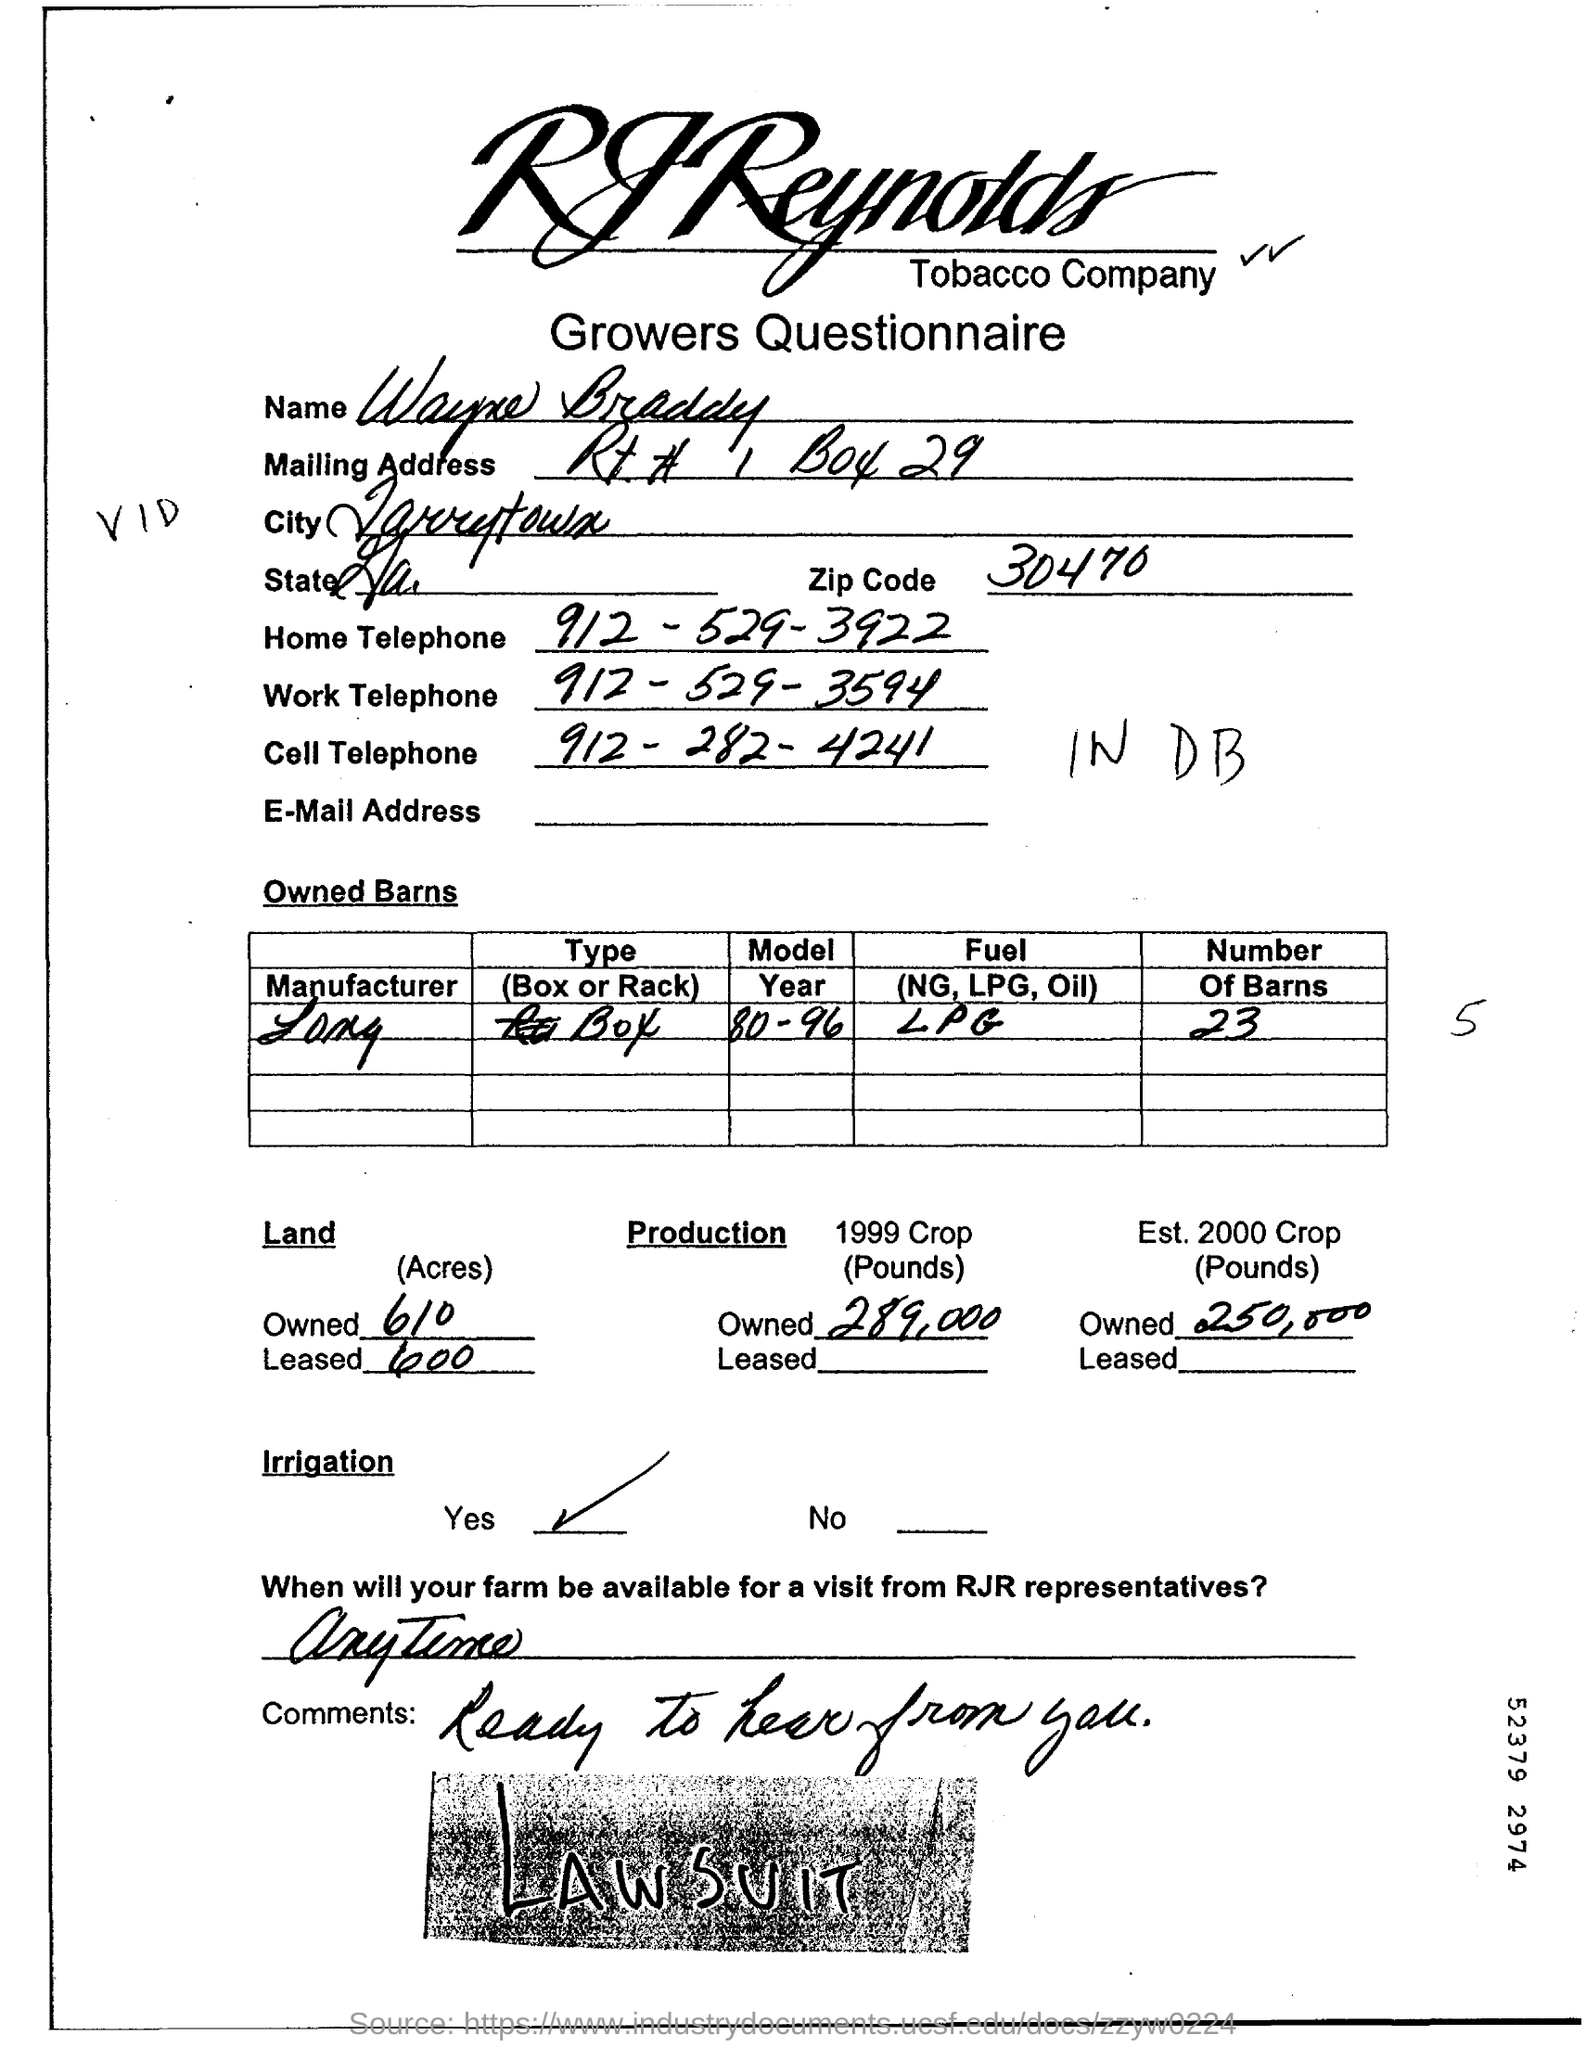What is the Zip code?
Give a very brief answer. 30470. What is the Home Telephone number?
Give a very brief answer. 912-529-3922. 